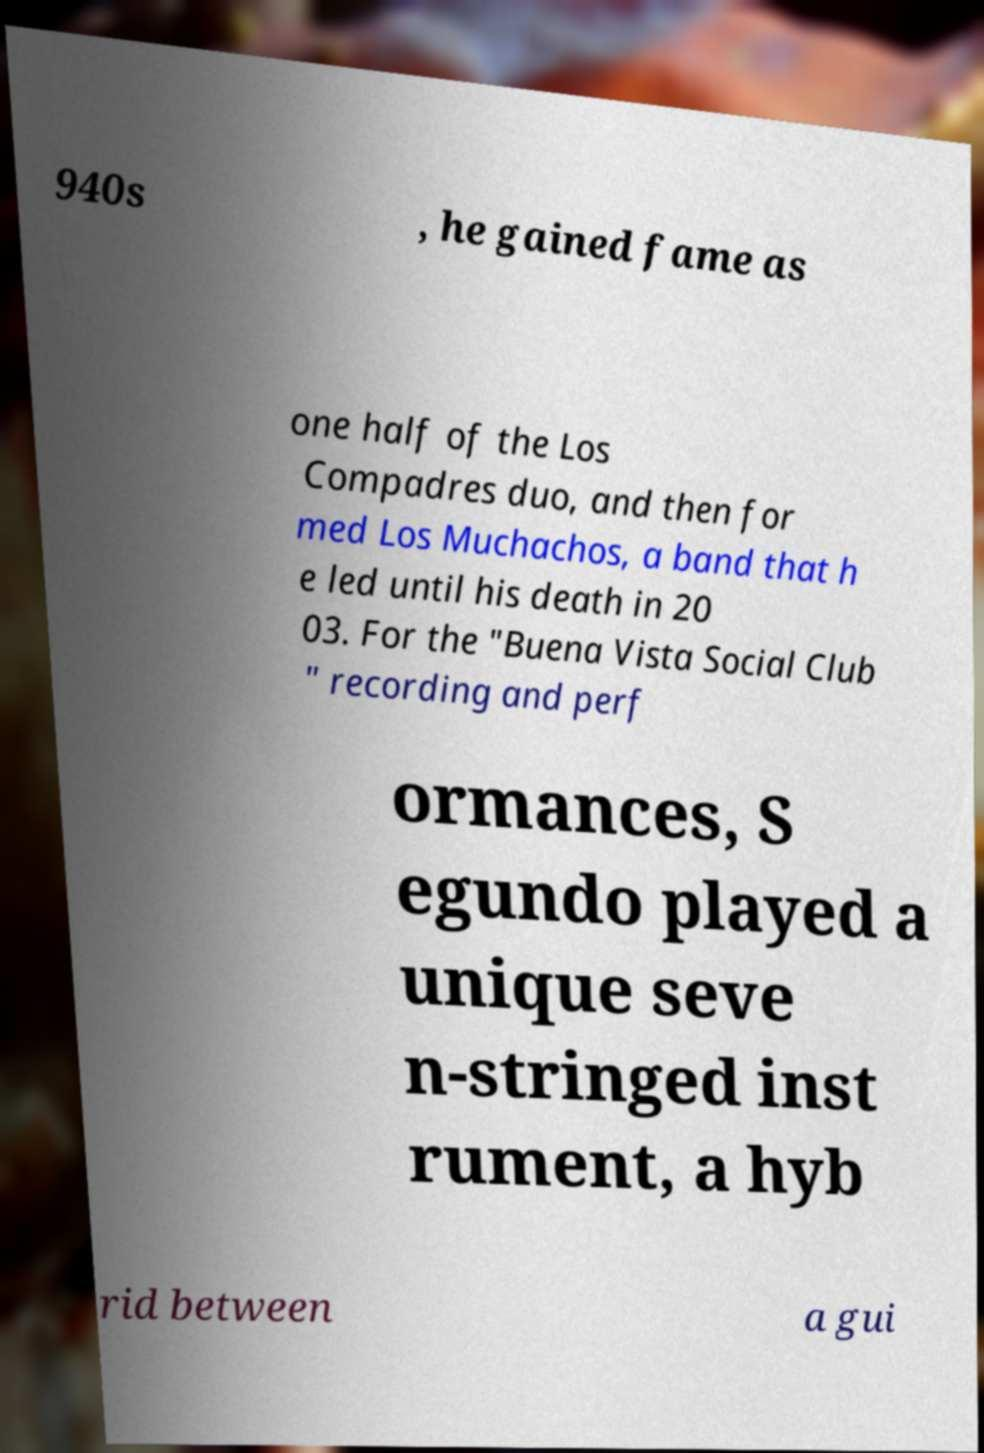What messages or text are displayed in this image? I need them in a readable, typed format. 940s , he gained fame as one half of the Los Compadres duo, and then for med Los Muchachos, a band that h e led until his death in 20 03. For the "Buena Vista Social Club " recording and perf ormances, S egundo played a unique seve n-stringed inst rument, a hyb rid between a gui 